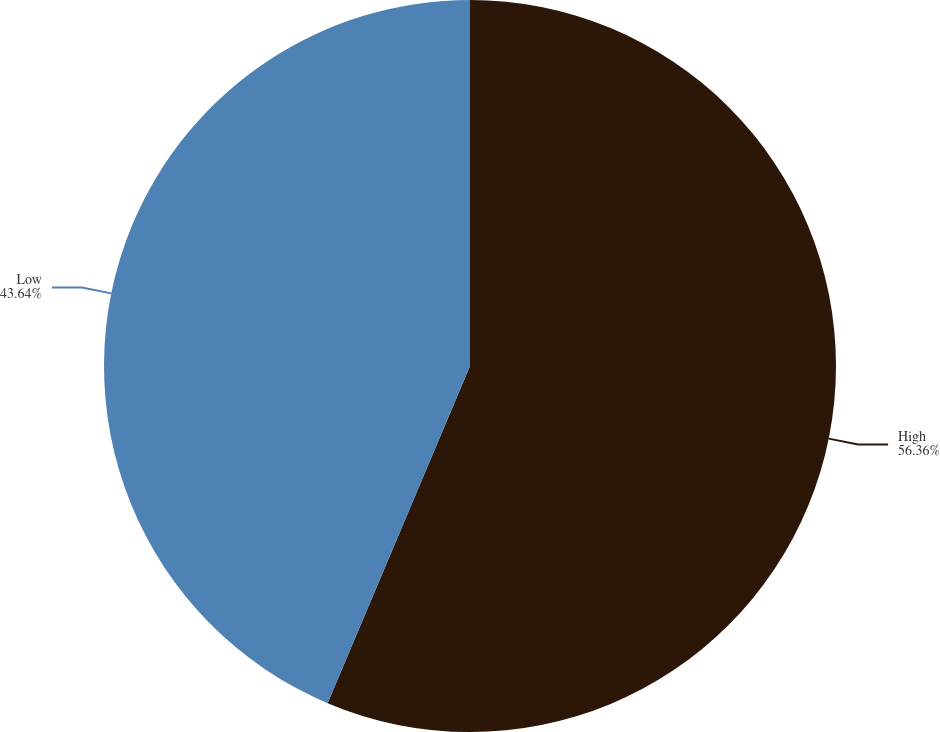<chart> <loc_0><loc_0><loc_500><loc_500><pie_chart><fcel>High<fcel>Low<nl><fcel>56.36%<fcel>43.64%<nl></chart> 